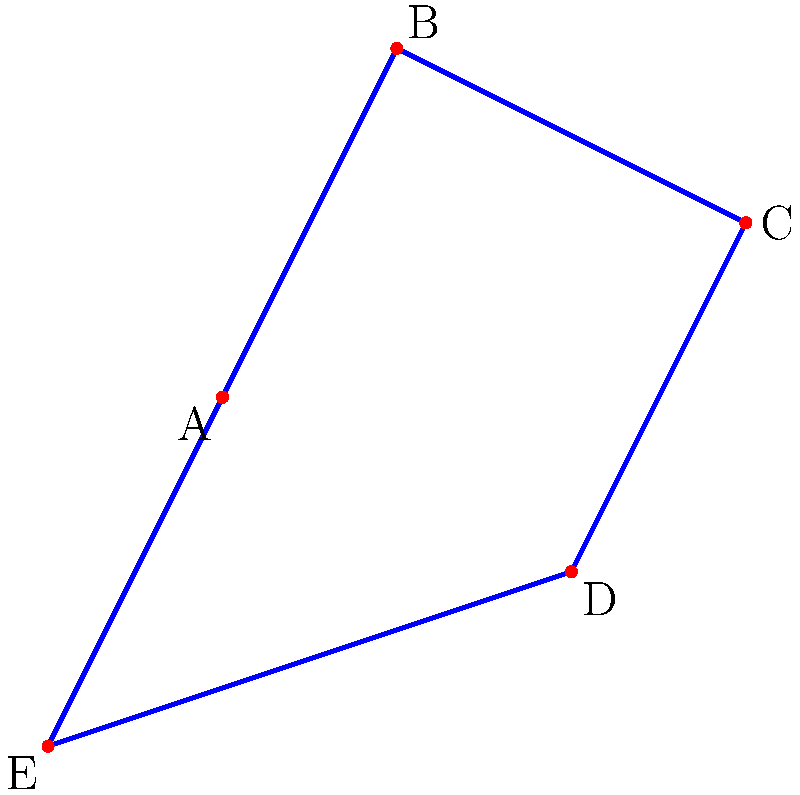In your role analyzing sales data patterns, you've encountered a star pattern resembling a constellation. Based on the configuration shown, which well-known constellation does this pattern most closely resemble? To identify this constellation, let's analyze the star pattern step-by-step:

1. The pattern shows 5 bright stars connected in a pentagonal shape.
2. The stars are not evenly spaced, creating an irregular pentagon.
3. There's a distinctive "W" or "M" shape formed by stars A, B, C, and D.
4. Star E is positioned below this "W" shape, creating a chair-like appearance.
5. This configuration is characteristic of the constellation Cassiopeia.

Cassiopeia is known for its distinctive W or M shape, depending on its orientation in the sky. It's one of the most recognizable constellations in the northern hemisphere.

The pattern shown closely matches Cassiopeia's key features:
- The W/M shape formed by 4 of the stars
- The 5th star completing the chair or throne shape

In your data analysis work, recognizing patterns like this can be crucial for identifying trends or anomalies in sales data, similar to how astronomers use star patterns to navigate the night sky.
Answer: Cassiopeia 